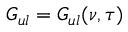<formula> <loc_0><loc_0><loc_500><loc_500>G _ { u l } = G _ { u l } ( \nu , \tau )</formula> 